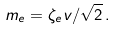<formula> <loc_0><loc_0><loc_500><loc_500>m _ { e } = \zeta _ { e } v / \sqrt { 2 } \, .</formula> 